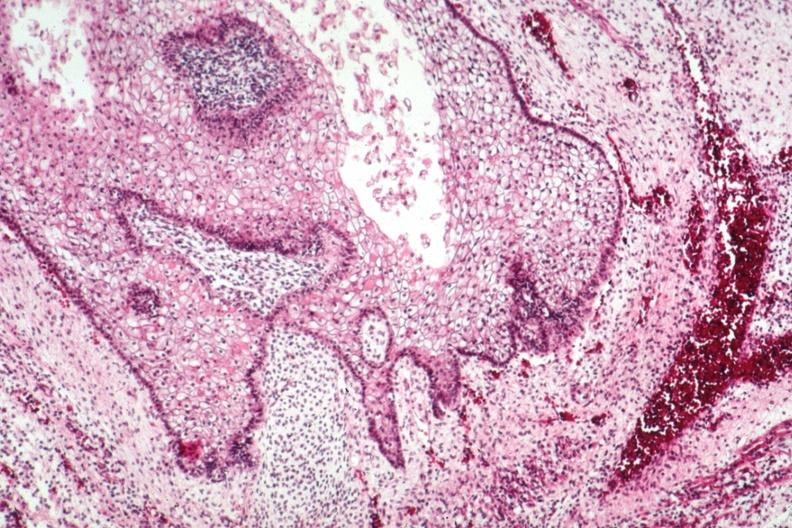s sacrococcygeal teratoma present?
Answer the question using a single word or phrase. Yes 